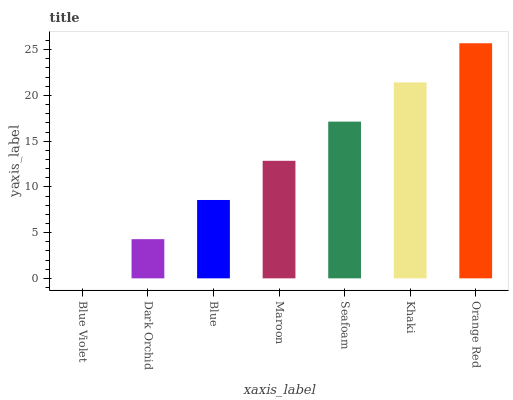Is Dark Orchid the minimum?
Answer yes or no. No. Is Dark Orchid the maximum?
Answer yes or no. No. Is Dark Orchid greater than Blue Violet?
Answer yes or no. Yes. Is Blue Violet less than Dark Orchid?
Answer yes or no. Yes. Is Blue Violet greater than Dark Orchid?
Answer yes or no. No. Is Dark Orchid less than Blue Violet?
Answer yes or no. No. Is Maroon the high median?
Answer yes or no. Yes. Is Maroon the low median?
Answer yes or no. Yes. Is Dark Orchid the high median?
Answer yes or no. No. Is Dark Orchid the low median?
Answer yes or no. No. 